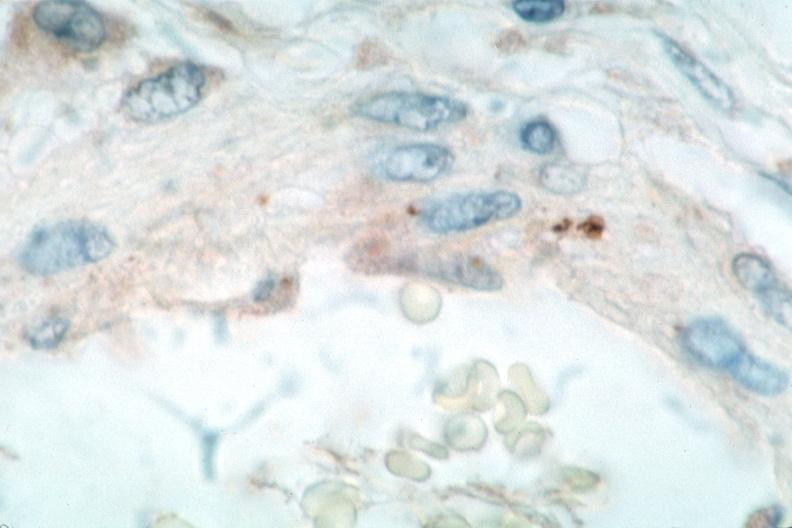s vasculature present?
Answer the question using a single word or phrase. Yes 